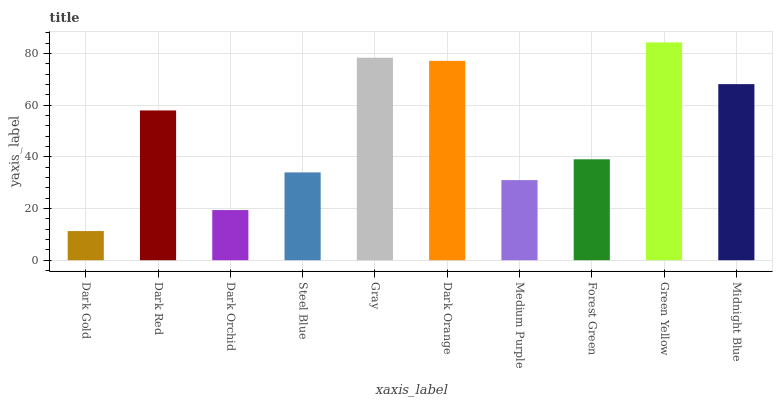Is Dark Red the minimum?
Answer yes or no. No. Is Dark Red the maximum?
Answer yes or no. No. Is Dark Red greater than Dark Gold?
Answer yes or no. Yes. Is Dark Gold less than Dark Red?
Answer yes or no. Yes. Is Dark Gold greater than Dark Red?
Answer yes or no. No. Is Dark Red less than Dark Gold?
Answer yes or no. No. Is Dark Red the high median?
Answer yes or no. Yes. Is Forest Green the low median?
Answer yes or no. Yes. Is Dark Orchid the high median?
Answer yes or no. No. Is Dark Red the low median?
Answer yes or no. No. 